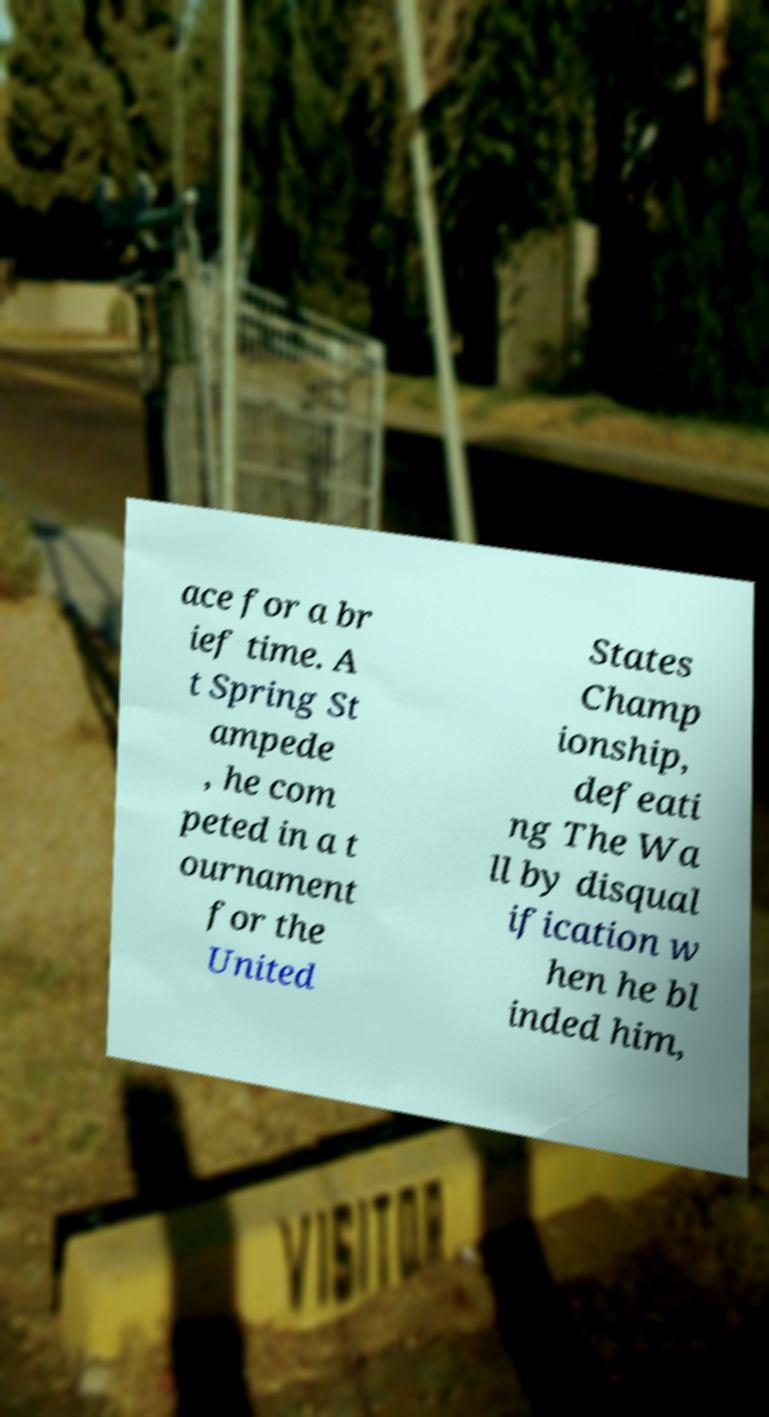Could you extract and type out the text from this image? ace for a br ief time. A t Spring St ampede , he com peted in a t ournament for the United States Champ ionship, defeati ng The Wa ll by disqual ification w hen he bl inded him, 